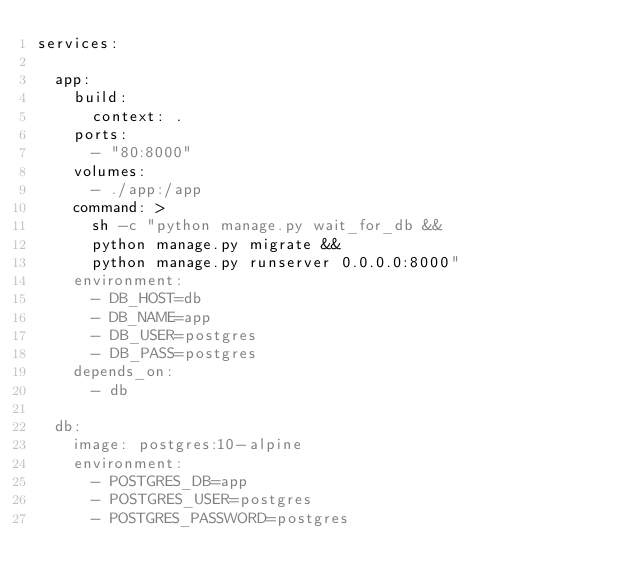<code> <loc_0><loc_0><loc_500><loc_500><_YAML_>services:

  app:
    build:
      context: .
    ports:
      - "80:8000"
    volumes:
      - ./app:/app
    command: >
      sh -c "python manage.py wait_for_db &&
      python manage.py migrate &&
      python manage.py runserver 0.0.0.0:8000"
    environment:
      - DB_HOST=db
      - DB_NAME=app
      - DB_USER=postgres
      - DB_PASS=postgres
    depends_on:
      - db

  db:
    image: postgres:10-alpine
    environment:
      - POSTGRES_DB=app
      - POSTGRES_USER=postgres
      - POSTGRES_PASSWORD=postgres
</code> 